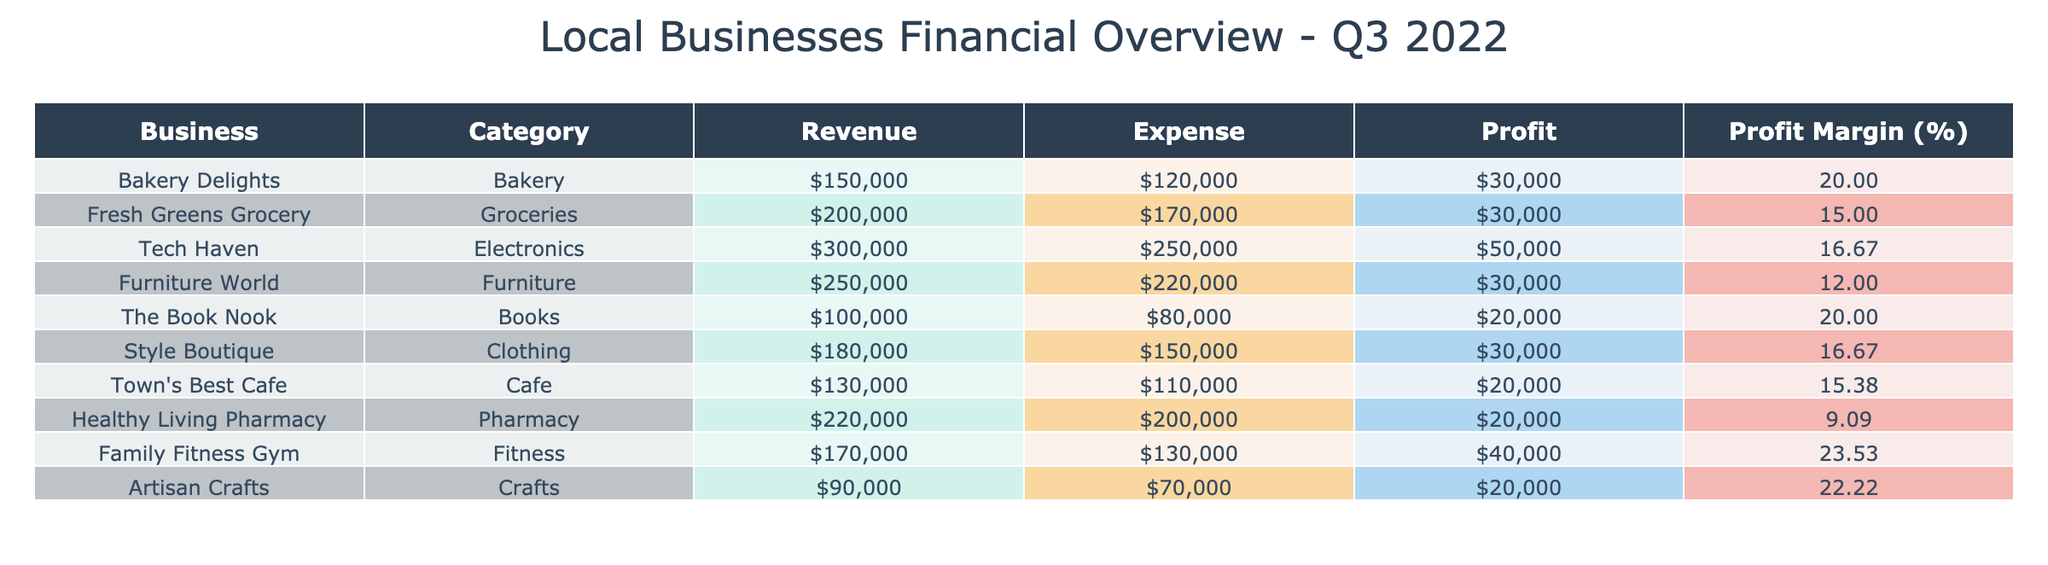What is the revenue of Style Boutique? The table shows that the revenue for Style Boutique is listed under the Revenue column, which indicates a value of 180,000.
Answer: 180,000 Which business has the highest profit margin? To find the highest profit margin, we look at the Profit Margin column. The values are calculated as (Revenue - Expense) / Revenue * 100. Tech Haven has a profit margin of 16.67%, while Fresh Greens Grocery has 15%, and other businesses have lower margins, confirming that Tech Haven is indeed the highest.
Answer: Tech Haven What is the total revenue of all businesses combined? We sum the Revenue column values: (150,000 + 200,000 + 300,000 + 250,000 + 100,000 + 180,000 + 130,000 + 220,000 + 170,000 + 90,000) = 1,690,000.
Answer: 1,690,000 Is the total expense of Healthy Living Pharmacy greater than the total expense of Bakery Delights? The expenses for Healthy Living Pharmacy are 200,000, while for Bakery Delights, they are 120,000. Comparing these values indicates that 200,000 is greater than 120,000, thus this statement is true.
Answer: Yes Calculate the average profit of all listed businesses. First, we locate the Profits for each business: Bakery Delights (30,000), Fresh Greens Grocery (30,000), Tech Haven (50,000), Furniture World (30,000), The Book Nook (20,000), Style Boutique (30,000), Town's Best Cafe (20,000), Healthy Living Pharmacy (20,000), Family Fitness Gym (40,000), Artisan Crafts (20,000). Adding these gives a total profit of 390,000. Dividing by the number of businesses (10) gives an average profit of 39,000.
Answer: 39,000 